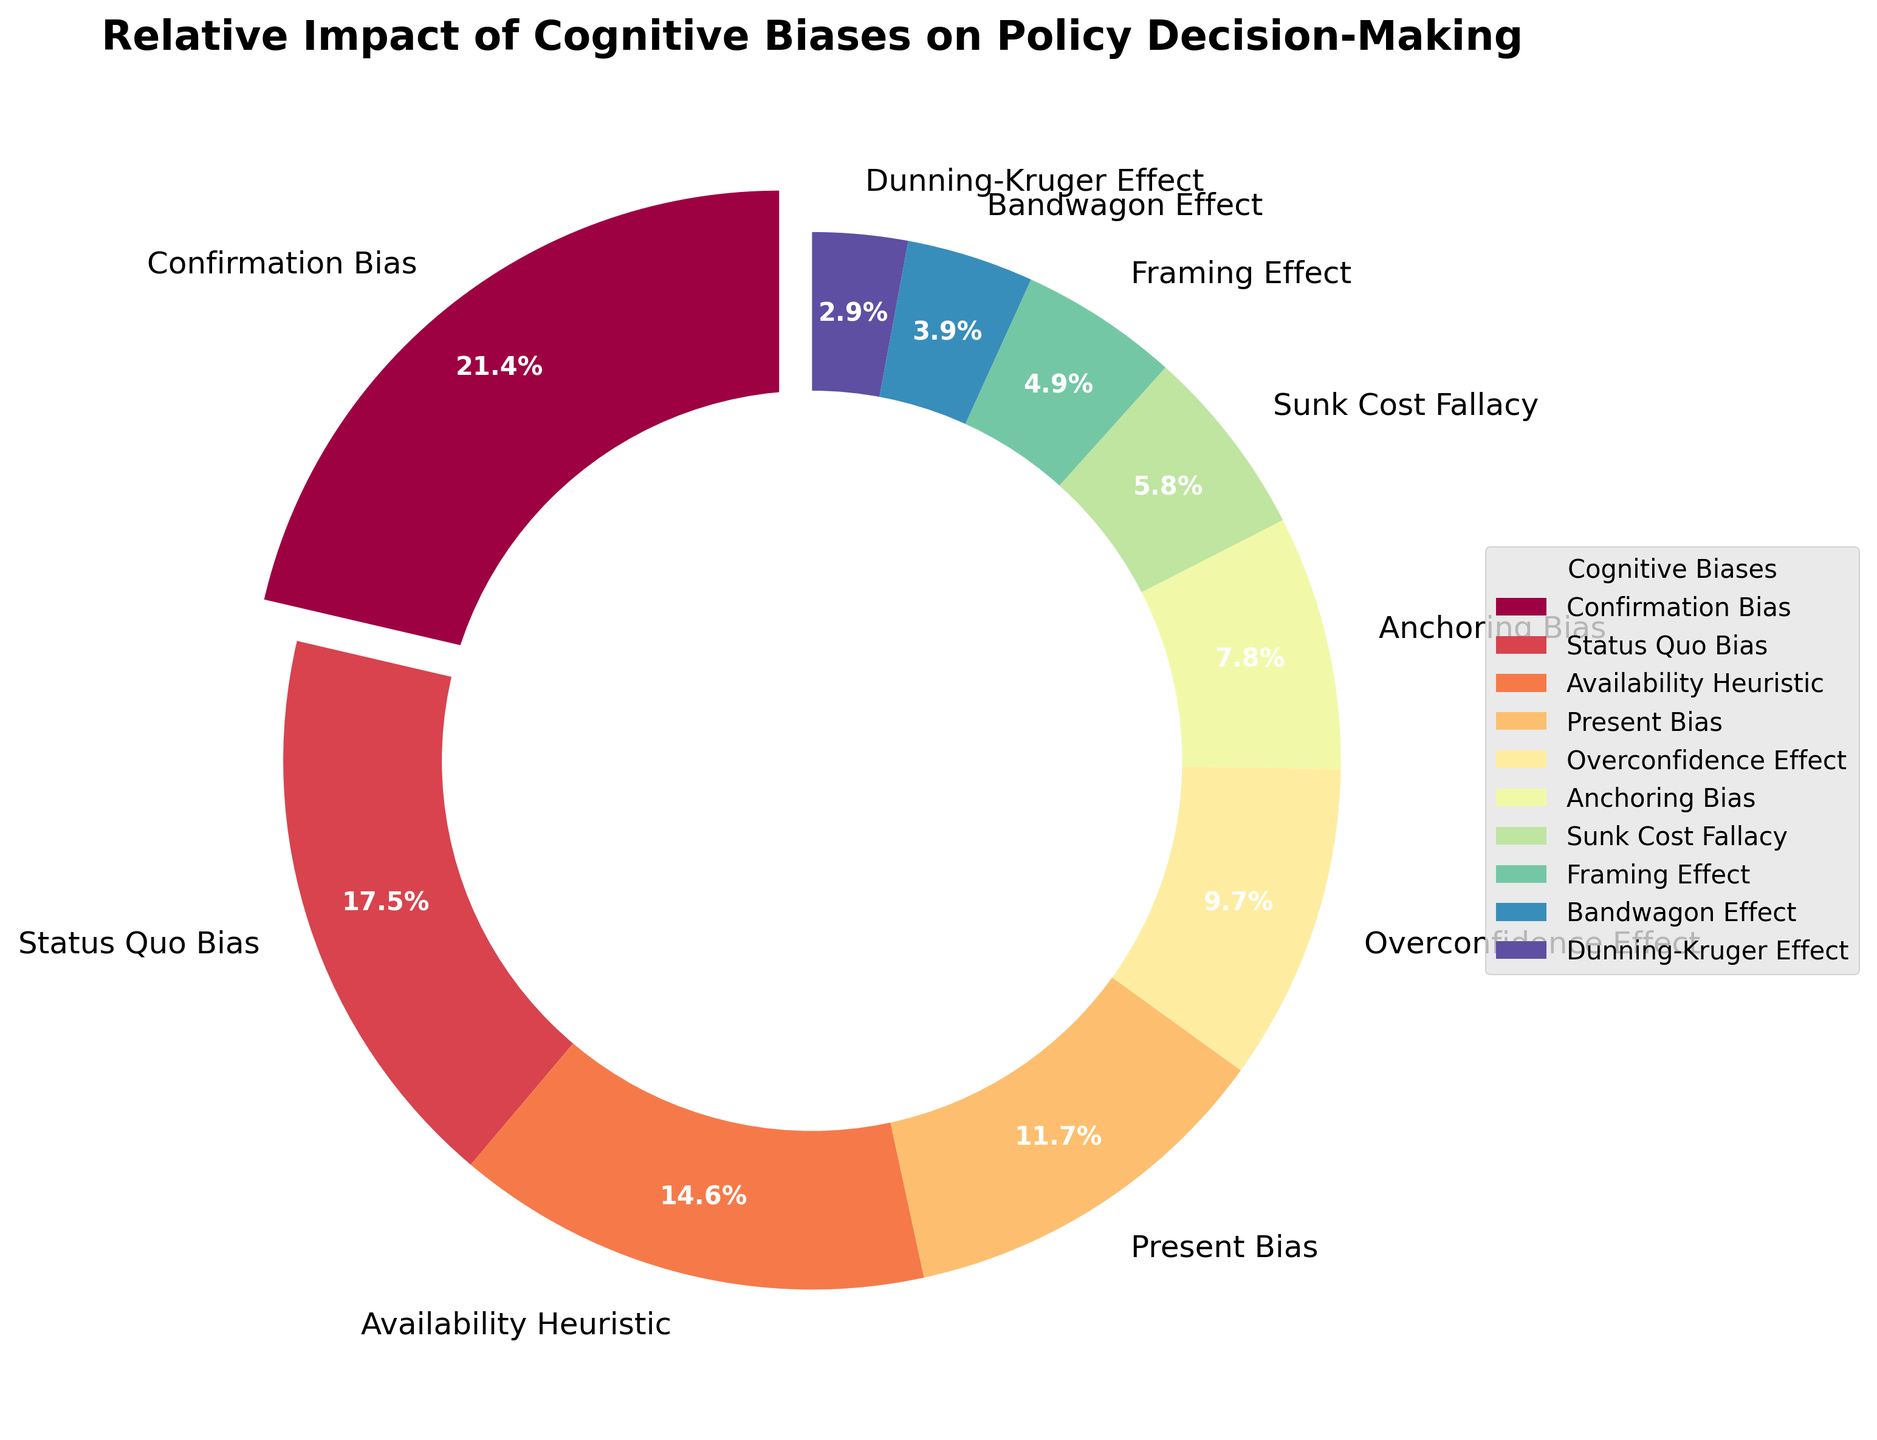What's the impact percentage of Confirmation Bias? Look at the wedge labeled "Confirmation Bias" on the pie chart. The percentage is provided on the wedge.
Answer: 22% Which cognitive bias has the lowest impact on policy decision-making? Identify the smallest wedge in the pie chart and read its label.
Answer: Dunning-Kruger Effect What is the combined impact of Availability Heuristic and Present Bias? Find the wedges labeled "Availability Heuristic" and "Present Bias". Add their percentages (15% + 12%).
Answer: 27% How does the impact of Status Quo Bias compare to Overconfidence Effect? Locate the wedges for both biases and compare their percentages directly. Status Quo Bias has 18% while Overconfidence Effect has 10%.
Answer: Status Quo Bias has a higher impact than Overconfidence Effect What is the total impact percentage of the biases less than 10%? Identify and sum the percentages of all biases below 10%: Anchoring Bias (8%), Sunk Cost Fallacy (6%), Framing Effect (5%), Bandwagon Effect (4%), and Dunning-Kruger Effect (3%). (8% + 6% + 5% + 4% + 3%)
Answer: 26% Which wedge is represented with the darkest color? The pie chart uses a color gradient; the darkest color will be assigned to the wedge at one end of the spectrum. Confirmation Bias, the largest segment, is likely represented with the darkest color in a typical gradient.
Answer: Confirmation Bias What is the difference in impact between the Sunk Cost Fallacy and Framing Effect? Subtract the percentage of Framing Effect from Sunk Cost Fallacy (6% - 5%).
Answer: 1% How many cognitive biases have an impact greater than or equal to 15%? Count the wedges with percentages 15% or higher (Confirmation Bias: 22%, Status Quo Bias: 18%, Availability Heuristic: 15%).
Answer: 3 Describe the visual distribution pattern of the cognitive biases in the pie chart. The largest wedges (Confirmation Bias, Status Quo Bias) are clustered together, followed by moderately large ones (Availability Heuristic, Present Bias). Smaller wedges make up the rest, highlighted by their distinct, evenly-spaced intervals.
Answer: Largest biases grouped; smaller evenly spaced Which biases have an impact close to the average of all biases? Calculate the average impact: (22 + 18 + 15 + 12 + 10 + 8 + 6 + 5 + 4 + 3) / 10 = 10.3%. Identify biases near this value (Overconfidence Effect: 10%, Present Bias: 12%).
Answer: Overconfidence Effect, Present Bias 